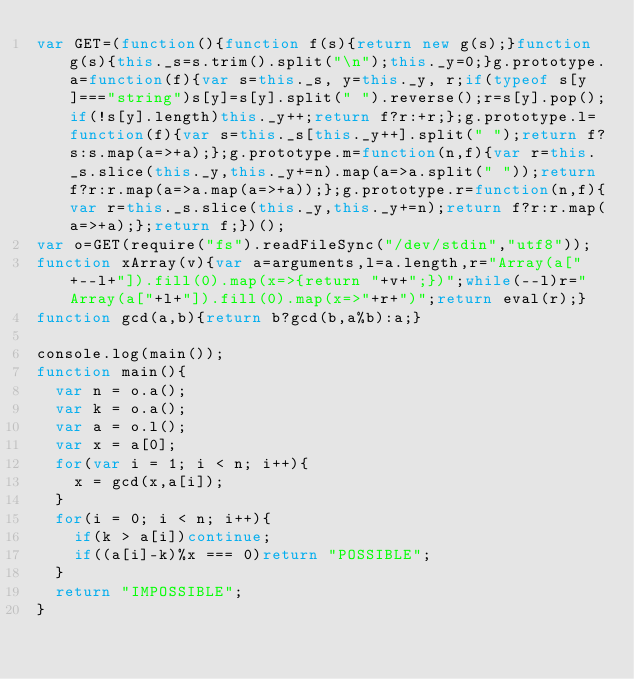Convert code to text. <code><loc_0><loc_0><loc_500><loc_500><_JavaScript_>var GET=(function(){function f(s){return new g(s);}function g(s){this._s=s.trim().split("\n");this._y=0;}g.prototype.a=function(f){var s=this._s, y=this._y, r;if(typeof s[y]==="string")s[y]=s[y].split(" ").reverse();r=s[y].pop();if(!s[y].length)this._y++;return f?r:+r;};g.prototype.l=function(f){var s=this._s[this._y++].split(" ");return f?s:s.map(a=>+a);};g.prototype.m=function(n,f){var r=this._s.slice(this._y,this._y+=n).map(a=>a.split(" "));return f?r:r.map(a=>a.map(a=>+a));};g.prototype.r=function(n,f){var r=this._s.slice(this._y,this._y+=n);return f?r:r.map(a=>+a);};return f;})();
var o=GET(require("fs").readFileSync("/dev/stdin","utf8"));
function xArray(v){var a=arguments,l=a.length,r="Array(a["+--l+"]).fill(0).map(x=>{return "+v+";})";while(--l)r="Array(a["+l+"]).fill(0).map(x=>"+r+")";return eval(r);}
function gcd(a,b){return b?gcd(b,a%b):a;}

console.log(main());
function main(){
  var n = o.a();
  var k = o.a();
  var a = o.l();
  var x = a[0];
  for(var i = 1; i < n; i++){
    x = gcd(x,a[i]);
  }
  for(i = 0; i < n; i++){
    if(k > a[i])continue;
    if((a[i]-k)%x === 0)return "POSSIBLE";
  }
  return "IMPOSSIBLE";
}</code> 